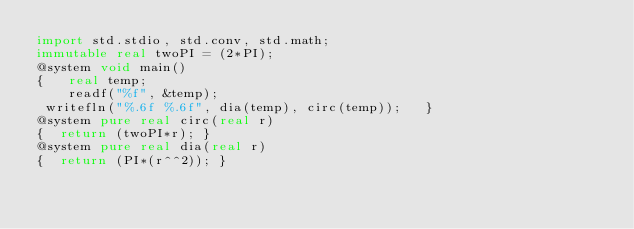Convert code to text. <code><loc_0><loc_0><loc_500><loc_500><_D_>import std.stdio, std.conv, std.math;
immutable real twoPI = (2*PI);
@system void main()
{   real temp;
    readf("%f", &temp);
 writefln("%.6f %.6f", dia(temp), circ(temp));   }
@system pure real circ(real r)
{  return (twoPI*r); }
@system pure real dia(real r)
{  return (PI*(r^^2)); }</code> 